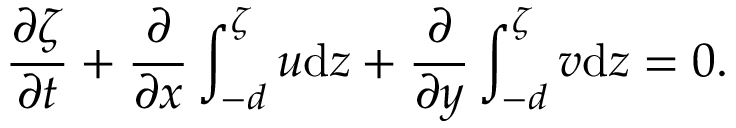<formula> <loc_0><loc_0><loc_500><loc_500>\frac { \partial \zeta } { \partial t } + \frac { \partial } { \partial x } \int _ { - d } ^ { \zeta } u d z + \frac { \partial } { \partial y } \int _ { - d } ^ { \zeta } v d z = 0 .</formula> 